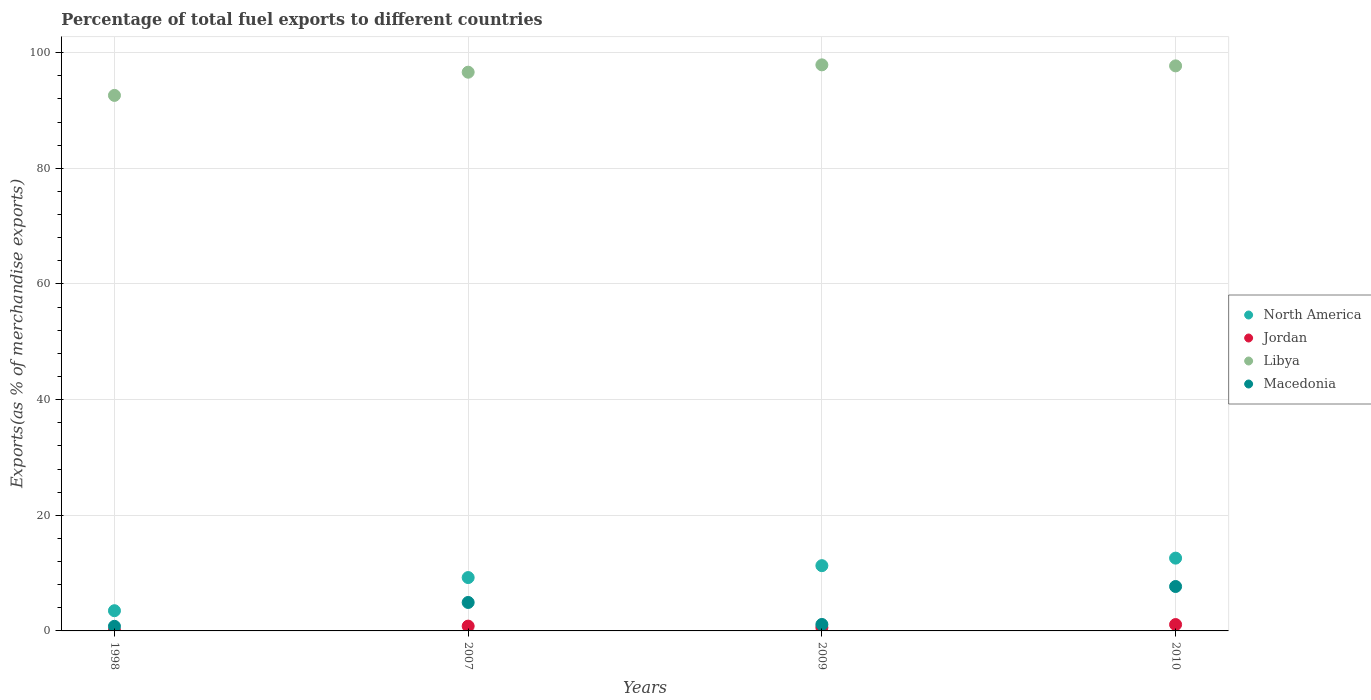What is the percentage of exports to different countries in Jordan in 2007?
Give a very brief answer. 0.83. Across all years, what is the maximum percentage of exports to different countries in Libya?
Ensure brevity in your answer.  97.89. Across all years, what is the minimum percentage of exports to different countries in Libya?
Make the answer very short. 92.61. In which year was the percentage of exports to different countries in Macedonia maximum?
Make the answer very short. 2010. In which year was the percentage of exports to different countries in North America minimum?
Ensure brevity in your answer.  1998. What is the total percentage of exports to different countries in Jordan in the graph?
Provide a succinct answer. 2.58. What is the difference between the percentage of exports to different countries in North America in 2007 and that in 2009?
Ensure brevity in your answer.  -2.06. What is the difference between the percentage of exports to different countries in Libya in 1998 and the percentage of exports to different countries in North America in 2010?
Make the answer very short. 80.02. What is the average percentage of exports to different countries in Jordan per year?
Your answer should be compact. 0.64. In the year 2010, what is the difference between the percentage of exports to different countries in Libya and percentage of exports to different countries in Macedonia?
Ensure brevity in your answer.  90.04. In how many years, is the percentage of exports to different countries in Macedonia greater than 24 %?
Provide a short and direct response. 0. What is the ratio of the percentage of exports to different countries in North America in 2009 to that in 2010?
Keep it short and to the point. 0.9. Is the difference between the percentage of exports to different countries in Libya in 2009 and 2010 greater than the difference between the percentage of exports to different countries in Macedonia in 2009 and 2010?
Provide a short and direct response. Yes. What is the difference between the highest and the second highest percentage of exports to different countries in North America?
Your response must be concise. 1.3. What is the difference between the highest and the lowest percentage of exports to different countries in Macedonia?
Provide a succinct answer. 6.88. Is the sum of the percentage of exports to different countries in Jordan in 2009 and 2010 greater than the maximum percentage of exports to different countries in North America across all years?
Keep it short and to the point. No. Is it the case that in every year, the sum of the percentage of exports to different countries in Jordan and percentage of exports to different countries in North America  is greater than the sum of percentage of exports to different countries in Libya and percentage of exports to different countries in Macedonia?
Provide a succinct answer. No. Is it the case that in every year, the sum of the percentage of exports to different countries in Jordan and percentage of exports to different countries in North America  is greater than the percentage of exports to different countries in Libya?
Your answer should be compact. No. Does the percentage of exports to different countries in North America monotonically increase over the years?
Give a very brief answer. Yes. Is the percentage of exports to different countries in Jordan strictly greater than the percentage of exports to different countries in North America over the years?
Offer a terse response. No. Is the percentage of exports to different countries in Jordan strictly less than the percentage of exports to different countries in North America over the years?
Provide a succinct answer. Yes. How many dotlines are there?
Your answer should be very brief. 4. Does the graph contain grids?
Make the answer very short. Yes. Where does the legend appear in the graph?
Keep it short and to the point. Center right. How many legend labels are there?
Offer a very short reply. 4. How are the legend labels stacked?
Your answer should be compact. Vertical. What is the title of the graph?
Keep it short and to the point. Percentage of total fuel exports to different countries. Does "Bahrain" appear as one of the legend labels in the graph?
Your answer should be very brief. No. What is the label or title of the Y-axis?
Offer a very short reply. Exports(as % of merchandise exports). What is the Exports(as % of merchandise exports) in North America in 1998?
Your response must be concise. 3.5. What is the Exports(as % of merchandise exports) of Jordan in 1998?
Your response must be concise. 0.07. What is the Exports(as % of merchandise exports) in Libya in 1998?
Your response must be concise. 92.61. What is the Exports(as % of merchandise exports) of Macedonia in 1998?
Ensure brevity in your answer.  0.8. What is the Exports(as % of merchandise exports) in North America in 2007?
Your answer should be very brief. 9.23. What is the Exports(as % of merchandise exports) of Jordan in 2007?
Ensure brevity in your answer.  0.83. What is the Exports(as % of merchandise exports) in Libya in 2007?
Your answer should be compact. 96.62. What is the Exports(as % of merchandise exports) of Macedonia in 2007?
Make the answer very short. 4.92. What is the Exports(as % of merchandise exports) in North America in 2009?
Your answer should be very brief. 11.28. What is the Exports(as % of merchandise exports) in Jordan in 2009?
Ensure brevity in your answer.  0.58. What is the Exports(as % of merchandise exports) in Libya in 2009?
Offer a terse response. 97.89. What is the Exports(as % of merchandise exports) in Macedonia in 2009?
Provide a succinct answer. 1.12. What is the Exports(as % of merchandise exports) in North America in 2010?
Provide a short and direct response. 12.59. What is the Exports(as % of merchandise exports) in Jordan in 2010?
Keep it short and to the point. 1.1. What is the Exports(as % of merchandise exports) in Libya in 2010?
Provide a short and direct response. 97.72. What is the Exports(as % of merchandise exports) in Macedonia in 2010?
Your response must be concise. 7.68. Across all years, what is the maximum Exports(as % of merchandise exports) in North America?
Provide a succinct answer. 12.59. Across all years, what is the maximum Exports(as % of merchandise exports) in Jordan?
Provide a succinct answer. 1.1. Across all years, what is the maximum Exports(as % of merchandise exports) of Libya?
Give a very brief answer. 97.89. Across all years, what is the maximum Exports(as % of merchandise exports) in Macedonia?
Give a very brief answer. 7.68. Across all years, what is the minimum Exports(as % of merchandise exports) of North America?
Offer a very short reply. 3.5. Across all years, what is the minimum Exports(as % of merchandise exports) in Jordan?
Keep it short and to the point. 0.07. Across all years, what is the minimum Exports(as % of merchandise exports) of Libya?
Offer a very short reply. 92.61. Across all years, what is the minimum Exports(as % of merchandise exports) of Macedonia?
Provide a short and direct response. 0.8. What is the total Exports(as % of merchandise exports) in North America in the graph?
Give a very brief answer. 36.6. What is the total Exports(as % of merchandise exports) in Jordan in the graph?
Ensure brevity in your answer.  2.58. What is the total Exports(as % of merchandise exports) in Libya in the graph?
Offer a very short reply. 384.85. What is the total Exports(as % of merchandise exports) in Macedonia in the graph?
Make the answer very short. 14.52. What is the difference between the Exports(as % of merchandise exports) of North America in 1998 and that in 2007?
Provide a short and direct response. -5.73. What is the difference between the Exports(as % of merchandise exports) in Jordan in 1998 and that in 2007?
Offer a very short reply. -0.76. What is the difference between the Exports(as % of merchandise exports) of Libya in 1998 and that in 2007?
Provide a succinct answer. -4.01. What is the difference between the Exports(as % of merchandise exports) in Macedonia in 1998 and that in 2007?
Your answer should be very brief. -4.12. What is the difference between the Exports(as % of merchandise exports) of North America in 1998 and that in 2009?
Your answer should be compact. -7.79. What is the difference between the Exports(as % of merchandise exports) of Jordan in 1998 and that in 2009?
Provide a short and direct response. -0.51. What is the difference between the Exports(as % of merchandise exports) of Libya in 1998 and that in 2009?
Keep it short and to the point. -5.28. What is the difference between the Exports(as % of merchandise exports) in Macedonia in 1998 and that in 2009?
Give a very brief answer. -0.32. What is the difference between the Exports(as % of merchandise exports) in North America in 1998 and that in 2010?
Ensure brevity in your answer.  -9.09. What is the difference between the Exports(as % of merchandise exports) in Jordan in 1998 and that in 2010?
Make the answer very short. -1.03. What is the difference between the Exports(as % of merchandise exports) in Libya in 1998 and that in 2010?
Provide a short and direct response. -5.11. What is the difference between the Exports(as % of merchandise exports) of Macedonia in 1998 and that in 2010?
Your response must be concise. -6.88. What is the difference between the Exports(as % of merchandise exports) of North America in 2007 and that in 2009?
Give a very brief answer. -2.06. What is the difference between the Exports(as % of merchandise exports) of Jordan in 2007 and that in 2009?
Give a very brief answer. 0.25. What is the difference between the Exports(as % of merchandise exports) of Libya in 2007 and that in 2009?
Your answer should be very brief. -1.27. What is the difference between the Exports(as % of merchandise exports) in Macedonia in 2007 and that in 2009?
Ensure brevity in your answer.  3.8. What is the difference between the Exports(as % of merchandise exports) of North America in 2007 and that in 2010?
Your response must be concise. -3.36. What is the difference between the Exports(as % of merchandise exports) in Jordan in 2007 and that in 2010?
Provide a short and direct response. -0.27. What is the difference between the Exports(as % of merchandise exports) in Libya in 2007 and that in 2010?
Your answer should be very brief. -1.09. What is the difference between the Exports(as % of merchandise exports) of Macedonia in 2007 and that in 2010?
Provide a short and direct response. -2.76. What is the difference between the Exports(as % of merchandise exports) of North America in 2009 and that in 2010?
Offer a very short reply. -1.3. What is the difference between the Exports(as % of merchandise exports) in Jordan in 2009 and that in 2010?
Ensure brevity in your answer.  -0.52. What is the difference between the Exports(as % of merchandise exports) in Libya in 2009 and that in 2010?
Offer a terse response. 0.18. What is the difference between the Exports(as % of merchandise exports) in Macedonia in 2009 and that in 2010?
Make the answer very short. -6.56. What is the difference between the Exports(as % of merchandise exports) in North America in 1998 and the Exports(as % of merchandise exports) in Jordan in 2007?
Offer a very short reply. 2.67. What is the difference between the Exports(as % of merchandise exports) in North America in 1998 and the Exports(as % of merchandise exports) in Libya in 2007?
Keep it short and to the point. -93.13. What is the difference between the Exports(as % of merchandise exports) in North America in 1998 and the Exports(as % of merchandise exports) in Macedonia in 2007?
Offer a terse response. -1.43. What is the difference between the Exports(as % of merchandise exports) of Jordan in 1998 and the Exports(as % of merchandise exports) of Libya in 2007?
Your answer should be very brief. -96.55. What is the difference between the Exports(as % of merchandise exports) of Jordan in 1998 and the Exports(as % of merchandise exports) of Macedonia in 2007?
Your answer should be very brief. -4.85. What is the difference between the Exports(as % of merchandise exports) of Libya in 1998 and the Exports(as % of merchandise exports) of Macedonia in 2007?
Offer a terse response. 87.69. What is the difference between the Exports(as % of merchandise exports) in North America in 1998 and the Exports(as % of merchandise exports) in Jordan in 2009?
Provide a succinct answer. 2.92. What is the difference between the Exports(as % of merchandise exports) of North America in 1998 and the Exports(as % of merchandise exports) of Libya in 2009?
Your answer should be compact. -94.4. What is the difference between the Exports(as % of merchandise exports) in North America in 1998 and the Exports(as % of merchandise exports) in Macedonia in 2009?
Make the answer very short. 2.38. What is the difference between the Exports(as % of merchandise exports) of Jordan in 1998 and the Exports(as % of merchandise exports) of Libya in 2009?
Give a very brief answer. -97.82. What is the difference between the Exports(as % of merchandise exports) of Jordan in 1998 and the Exports(as % of merchandise exports) of Macedonia in 2009?
Keep it short and to the point. -1.05. What is the difference between the Exports(as % of merchandise exports) of Libya in 1998 and the Exports(as % of merchandise exports) of Macedonia in 2009?
Provide a short and direct response. 91.49. What is the difference between the Exports(as % of merchandise exports) in North America in 1998 and the Exports(as % of merchandise exports) in Jordan in 2010?
Offer a very short reply. 2.4. What is the difference between the Exports(as % of merchandise exports) of North America in 1998 and the Exports(as % of merchandise exports) of Libya in 2010?
Make the answer very short. -94.22. What is the difference between the Exports(as % of merchandise exports) in North America in 1998 and the Exports(as % of merchandise exports) in Macedonia in 2010?
Offer a terse response. -4.19. What is the difference between the Exports(as % of merchandise exports) of Jordan in 1998 and the Exports(as % of merchandise exports) of Libya in 2010?
Ensure brevity in your answer.  -97.65. What is the difference between the Exports(as % of merchandise exports) in Jordan in 1998 and the Exports(as % of merchandise exports) in Macedonia in 2010?
Your answer should be compact. -7.61. What is the difference between the Exports(as % of merchandise exports) of Libya in 1998 and the Exports(as % of merchandise exports) of Macedonia in 2010?
Your response must be concise. 84.93. What is the difference between the Exports(as % of merchandise exports) in North America in 2007 and the Exports(as % of merchandise exports) in Jordan in 2009?
Give a very brief answer. 8.65. What is the difference between the Exports(as % of merchandise exports) in North America in 2007 and the Exports(as % of merchandise exports) in Libya in 2009?
Your response must be concise. -88.67. What is the difference between the Exports(as % of merchandise exports) of North America in 2007 and the Exports(as % of merchandise exports) of Macedonia in 2009?
Provide a short and direct response. 8.11. What is the difference between the Exports(as % of merchandise exports) in Jordan in 2007 and the Exports(as % of merchandise exports) in Libya in 2009?
Make the answer very short. -97.07. What is the difference between the Exports(as % of merchandise exports) of Jordan in 2007 and the Exports(as % of merchandise exports) of Macedonia in 2009?
Ensure brevity in your answer.  -0.29. What is the difference between the Exports(as % of merchandise exports) in Libya in 2007 and the Exports(as % of merchandise exports) in Macedonia in 2009?
Keep it short and to the point. 95.51. What is the difference between the Exports(as % of merchandise exports) of North America in 2007 and the Exports(as % of merchandise exports) of Jordan in 2010?
Provide a short and direct response. 8.13. What is the difference between the Exports(as % of merchandise exports) in North America in 2007 and the Exports(as % of merchandise exports) in Libya in 2010?
Keep it short and to the point. -88.49. What is the difference between the Exports(as % of merchandise exports) of North America in 2007 and the Exports(as % of merchandise exports) of Macedonia in 2010?
Keep it short and to the point. 1.55. What is the difference between the Exports(as % of merchandise exports) in Jordan in 2007 and the Exports(as % of merchandise exports) in Libya in 2010?
Your response must be concise. -96.89. What is the difference between the Exports(as % of merchandise exports) of Jordan in 2007 and the Exports(as % of merchandise exports) of Macedonia in 2010?
Ensure brevity in your answer.  -6.85. What is the difference between the Exports(as % of merchandise exports) in Libya in 2007 and the Exports(as % of merchandise exports) in Macedonia in 2010?
Offer a terse response. 88.94. What is the difference between the Exports(as % of merchandise exports) in North America in 2009 and the Exports(as % of merchandise exports) in Jordan in 2010?
Keep it short and to the point. 10.18. What is the difference between the Exports(as % of merchandise exports) in North America in 2009 and the Exports(as % of merchandise exports) in Libya in 2010?
Make the answer very short. -86.43. What is the difference between the Exports(as % of merchandise exports) in North America in 2009 and the Exports(as % of merchandise exports) in Macedonia in 2010?
Your answer should be very brief. 3.6. What is the difference between the Exports(as % of merchandise exports) in Jordan in 2009 and the Exports(as % of merchandise exports) in Libya in 2010?
Offer a very short reply. -97.14. What is the difference between the Exports(as % of merchandise exports) of Jordan in 2009 and the Exports(as % of merchandise exports) of Macedonia in 2010?
Make the answer very short. -7.1. What is the difference between the Exports(as % of merchandise exports) of Libya in 2009 and the Exports(as % of merchandise exports) of Macedonia in 2010?
Provide a succinct answer. 90.21. What is the average Exports(as % of merchandise exports) in North America per year?
Your answer should be very brief. 9.15. What is the average Exports(as % of merchandise exports) of Jordan per year?
Your answer should be compact. 0.64. What is the average Exports(as % of merchandise exports) of Libya per year?
Keep it short and to the point. 96.21. What is the average Exports(as % of merchandise exports) in Macedonia per year?
Your response must be concise. 3.63. In the year 1998, what is the difference between the Exports(as % of merchandise exports) in North America and Exports(as % of merchandise exports) in Jordan?
Your answer should be compact. 3.42. In the year 1998, what is the difference between the Exports(as % of merchandise exports) in North America and Exports(as % of merchandise exports) in Libya?
Make the answer very short. -89.12. In the year 1998, what is the difference between the Exports(as % of merchandise exports) in North America and Exports(as % of merchandise exports) in Macedonia?
Keep it short and to the point. 2.7. In the year 1998, what is the difference between the Exports(as % of merchandise exports) of Jordan and Exports(as % of merchandise exports) of Libya?
Give a very brief answer. -92.54. In the year 1998, what is the difference between the Exports(as % of merchandise exports) in Jordan and Exports(as % of merchandise exports) in Macedonia?
Your answer should be compact. -0.73. In the year 1998, what is the difference between the Exports(as % of merchandise exports) in Libya and Exports(as % of merchandise exports) in Macedonia?
Offer a very short reply. 91.81. In the year 2007, what is the difference between the Exports(as % of merchandise exports) in North America and Exports(as % of merchandise exports) in Jordan?
Provide a short and direct response. 8.4. In the year 2007, what is the difference between the Exports(as % of merchandise exports) in North America and Exports(as % of merchandise exports) in Libya?
Ensure brevity in your answer.  -87.4. In the year 2007, what is the difference between the Exports(as % of merchandise exports) in North America and Exports(as % of merchandise exports) in Macedonia?
Your answer should be very brief. 4.31. In the year 2007, what is the difference between the Exports(as % of merchandise exports) of Jordan and Exports(as % of merchandise exports) of Libya?
Your response must be concise. -95.8. In the year 2007, what is the difference between the Exports(as % of merchandise exports) of Jordan and Exports(as % of merchandise exports) of Macedonia?
Your answer should be compact. -4.09. In the year 2007, what is the difference between the Exports(as % of merchandise exports) of Libya and Exports(as % of merchandise exports) of Macedonia?
Your answer should be compact. 91.7. In the year 2009, what is the difference between the Exports(as % of merchandise exports) in North America and Exports(as % of merchandise exports) in Jordan?
Offer a very short reply. 10.71. In the year 2009, what is the difference between the Exports(as % of merchandise exports) of North America and Exports(as % of merchandise exports) of Libya?
Give a very brief answer. -86.61. In the year 2009, what is the difference between the Exports(as % of merchandise exports) in North America and Exports(as % of merchandise exports) in Macedonia?
Your response must be concise. 10.17. In the year 2009, what is the difference between the Exports(as % of merchandise exports) in Jordan and Exports(as % of merchandise exports) in Libya?
Give a very brief answer. -97.32. In the year 2009, what is the difference between the Exports(as % of merchandise exports) of Jordan and Exports(as % of merchandise exports) of Macedonia?
Ensure brevity in your answer.  -0.54. In the year 2009, what is the difference between the Exports(as % of merchandise exports) in Libya and Exports(as % of merchandise exports) in Macedonia?
Your response must be concise. 96.78. In the year 2010, what is the difference between the Exports(as % of merchandise exports) in North America and Exports(as % of merchandise exports) in Jordan?
Provide a short and direct response. 11.49. In the year 2010, what is the difference between the Exports(as % of merchandise exports) in North America and Exports(as % of merchandise exports) in Libya?
Keep it short and to the point. -85.13. In the year 2010, what is the difference between the Exports(as % of merchandise exports) in North America and Exports(as % of merchandise exports) in Macedonia?
Keep it short and to the point. 4.91. In the year 2010, what is the difference between the Exports(as % of merchandise exports) of Jordan and Exports(as % of merchandise exports) of Libya?
Your answer should be very brief. -96.62. In the year 2010, what is the difference between the Exports(as % of merchandise exports) in Jordan and Exports(as % of merchandise exports) in Macedonia?
Offer a very short reply. -6.58. In the year 2010, what is the difference between the Exports(as % of merchandise exports) in Libya and Exports(as % of merchandise exports) in Macedonia?
Give a very brief answer. 90.04. What is the ratio of the Exports(as % of merchandise exports) of North America in 1998 to that in 2007?
Make the answer very short. 0.38. What is the ratio of the Exports(as % of merchandise exports) in Jordan in 1998 to that in 2007?
Your answer should be very brief. 0.09. What is the ratio of the Exports(as % of merchandise exports) in Libya in 1998 to that in 2007?
Offer a terse response. 0.96. What is the ratio of the Exports(as % of merchandise exports) in Macedonia in 1998 to that in 2007?
Your response must be concise. 0.16. What is the ratio of the Exports(as % of merchandise exports) in North America in 1998 to that in 2009?
Your response must be concise. 0.31. What is the ratio of the Exports(as % of merchandise exports) in Jordan in 1998 to that in 2009?
Give a very brief answer. 0.12. What is the ratio of the Exports(as % of merchandise exports) in Libya in 1998 to that in 2009?
Keep it short and to the point. 0.95. What is the ratio of the Exports(as % of merchandise exports) of Macedonia in 1998 to that in 2009?
Offer a terse response. 0.71. What is the ratio of the Exports(as % of merchandise exports) in North America in 1998 to that in 2010?
Your response must be concise. 0.28. What is the ratio of the Exports(as % of merchandise exports) in Jordan in 1998 to that in 2010?
Your response must be concise. 0.06. What is the ratio of the Exports(as % of merchandise exports) in Libya in 1998 to that in 2010?
Offer a very short reply. 0.95. What is the ratio of the Exports(as % of merchandise exports) of Macedonia in 1998 to that in 2010?
Your answer should be compact. 0.1. What is the ratio of the Exports(as % of merchandise exports) in North America in 2007 to that in 2009?
Provide a succinct answer. 0.82. What is the ratio of the Exports(as % of merchandise exports) in Jordan in 2007 to that in 2009?
Your answer should be compact. 1.43. What is the ratio of the Exports(as % of merchandise exports) of Macedonia in 2007 to that in 2009?
Provide a short and direct response. 4.4. What is the ratio of the Exports(as % of merchandise exports) of North America in 2007 to that in 2010?
Ensure brevity in your answer.  0.73. What is the ratio of the Exports(as % of merchandise exports) of Jordan in 2007 to that in 2010?
Keep it short and to the point. 0.75. What is the ratio of the Exports(as % of merchandise exports) in Macedonia in 2007 to that in 2010?
Keep it short and to the point. 0.64. What is the ratio of the Exports(as % of merchandise exports) of North America in 2009 to that in 2010?
Your answer should be very brief. 0.9. What is the ratio of the Exports(as % of merchandise exports) of Jordan in 2009 to that in 2010?
Ensure brevity in your answer.  0.53. What is the ratio of the Exports(as % of merchandise exports) of Libya in 2009 to that in 2010?
Ensure brevity in your answer.  1. What is the ratio of the Exports(as % of merchandise exports) in Macedonia in 2009 to that in 2010?
Ensure brevity in your answer.  0.15. What is the difference between the highest and the second highest Exports(as % of merchandise exports) in North America?
Offer a terse response. 1.3. What is the difference between the highest and the second highest Exports(as % of merchandise exports) in Jordan?
Keep it short and to the point. 0.27. What is the difference between the highest and the second highest Exports(as % of merchandise exports) of Libya?
Ensure brevity in your answer.  0.18. What is the difference between the highest and the second highest Exports(as % of merchandise exports) of Macedonia?
Your answer should be very brief. 2.76. What is the difference between the highest and the lowest Exports(as % of merchandise exports) of North America?
Offer a very short reply. 9.09. What is the difference between the highest and the lowest Exports(as % of merchandise exports) of Jordan?
Provide a succinct answer. 1.03. What is the difference between the highest and the lowest Exports(as % of merchandise exports) in Libya?
Provide a short and direct response. 5.28. What is the difference between the highest and the lowest Exports(as % of merchandise exports) in Macedonia?
Ensure brevity in your answer.  6.88. 